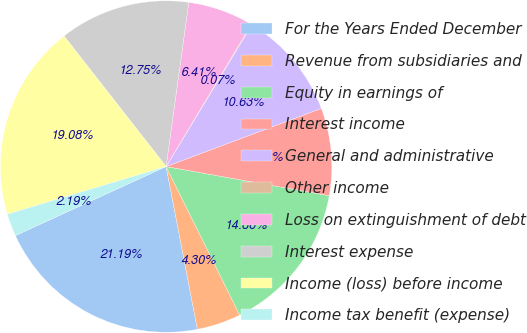Convert chart to OTSL. <chart><loc_0><loc_0><loc_500><loc_500><pie_chart><fcel>For the Years Ended December<fcel>Revenue from subsidiaries and<fcel>Equity in earnings of<fcel>Interest income<fcel>General and administrative<fcel>Other income<fcel>Loss on extinguishment of debt<fcel>Interest expense<fcel>Income (loss) before income<fcel>Income tax benefit (expense)<nl><fcel>21.19%<fcel>4.3%<fcel>14.86%<fcel>8.52%<fcel>10.63%<fcel>0.07%<fcel>6.41%<fcel>12.75%<fcel>19.08%<fcel>2.19%<nl></chart> 